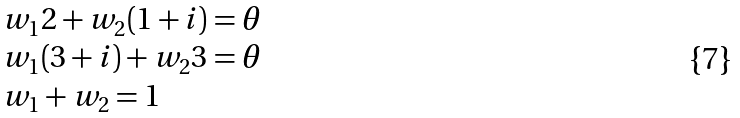Convert formula to latex. <formula><loc_0><loc_0><loc_500><loc_500>\begin{array} { l l } w _ { 1 } 2 + w _ { 2 } ( 1 + i ) = \theta \\ w _ { 1 } ( 3 + i ) + w _ { 2 } 3 = \theta \\ w _ { 1 } + w _ { 2 } = 1 \end{array}</formula> 